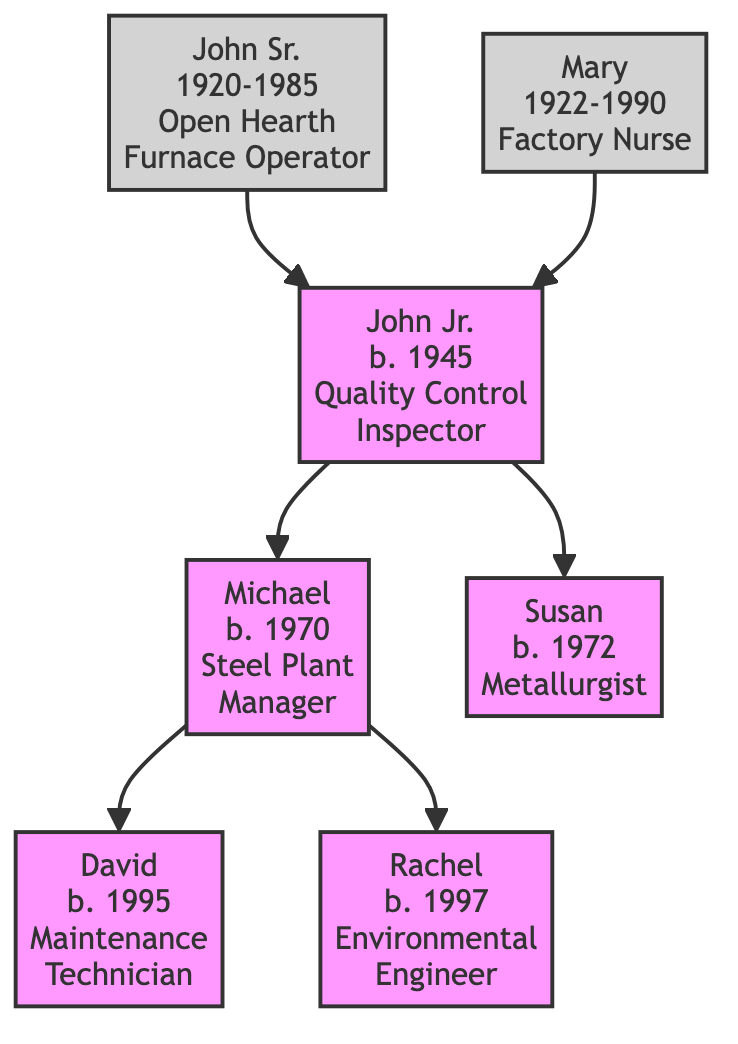What is the birth year of John Jr.? The diagram lists John Jr. with "b. 1945", indicating that he was born in 1945.
Answer: 1945 Who is the father of Michael? Looking at the diagram, we see an arrow leading from John Jr. to Michael, which signifies that John Jr. is Michael's father.
Answer: John Jr How many generations of steel workers are represented in the diagram? The diagram shows a total of three generations: John Sr., John Jr., and then his children Michael, Susan, David, and Rachel.
Answer: 3 What role does Rachel have in the steel industry? Rachel is mentioned in the diagram as an "Environmental Engineer," indicating her role within the industry.
Answer: Environmental Engineer Who worked as a Factory Nurse in the family? The diagram shows Mary labeled as the "Factory Nurse," indicating that she held that position.
Answer: Mary Which individual has the role of Quality Control Inspector? The diagram clearly identifies John Jr. as the "Quality Control Inspector."
Answer: John Jr How many children did John Jr. have? The diagram shows two arrows branching from John Jr. to Michael and Susan, indicating that he has two children.
Answer: 2 What is the relationship between Susan and John Sr.? Since John Jr. is the child of John Sr., and Susan is a child of John Jr., it follows that Susan is the granddaughter of John Sr.
Answer: Granddaughter What role does Michael hold in the steel plant? According to the diagram, Michael is positioned as the "Steel Plant Manager."
Answer: Steel Plant Manager 